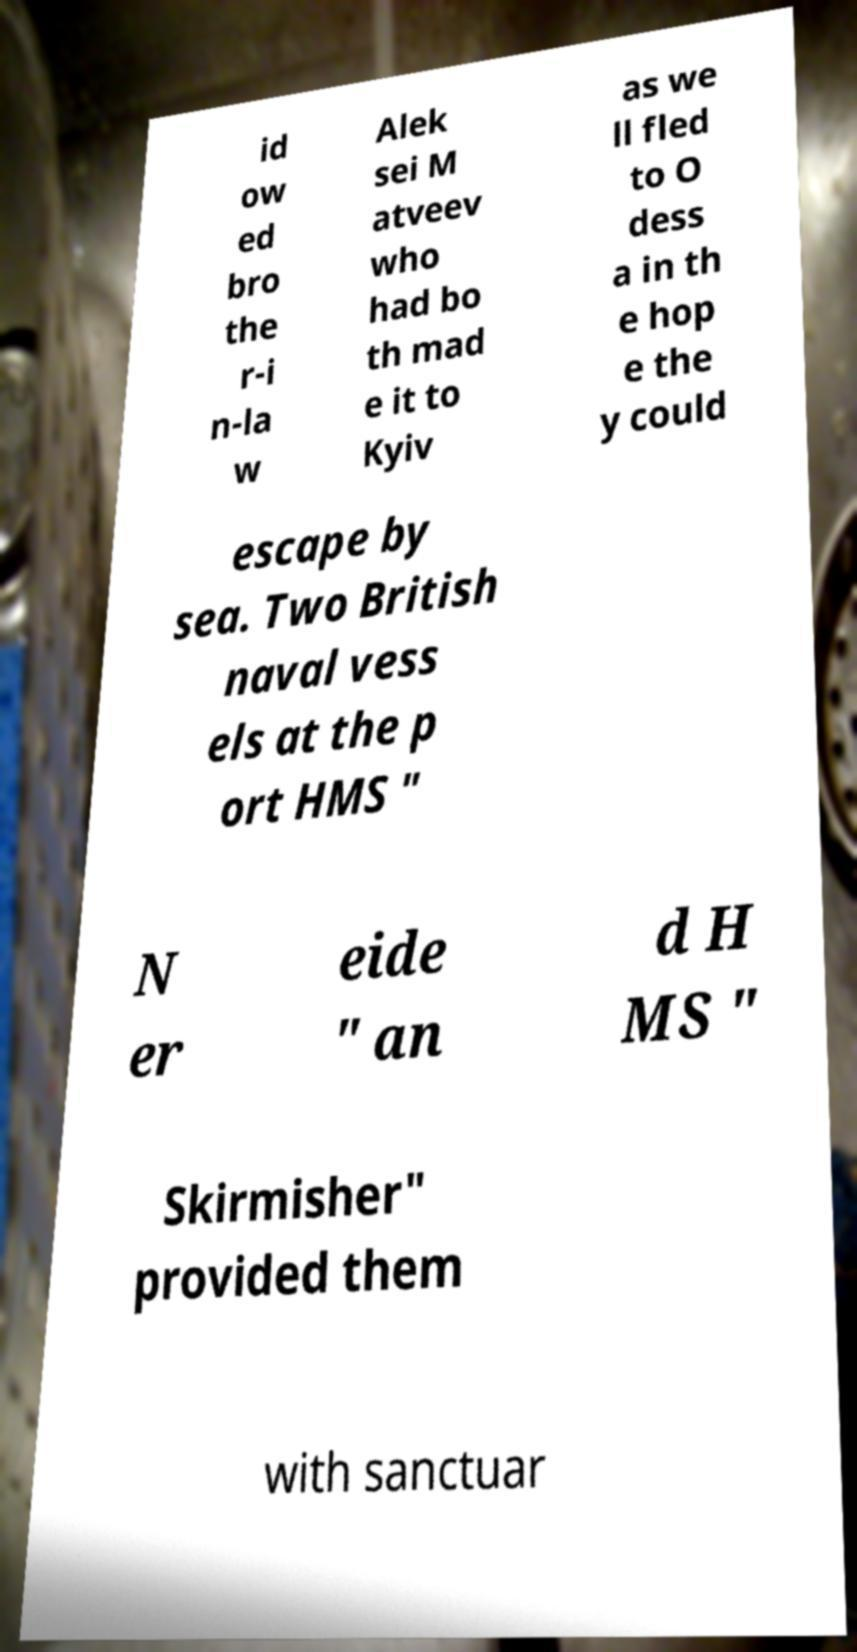I need the written content from this picture converted into text. Can you do that? id ow ed bro the r-i n-la w Alek sei M atveev who had bo th mad e it to Kyiv as we ll fled to O dess a in th e hop e the y could escape by sea. Two British naval vess els at the p ort HMS " N er eide " an d H MS " Skirmisher" provided them with sanctuar 